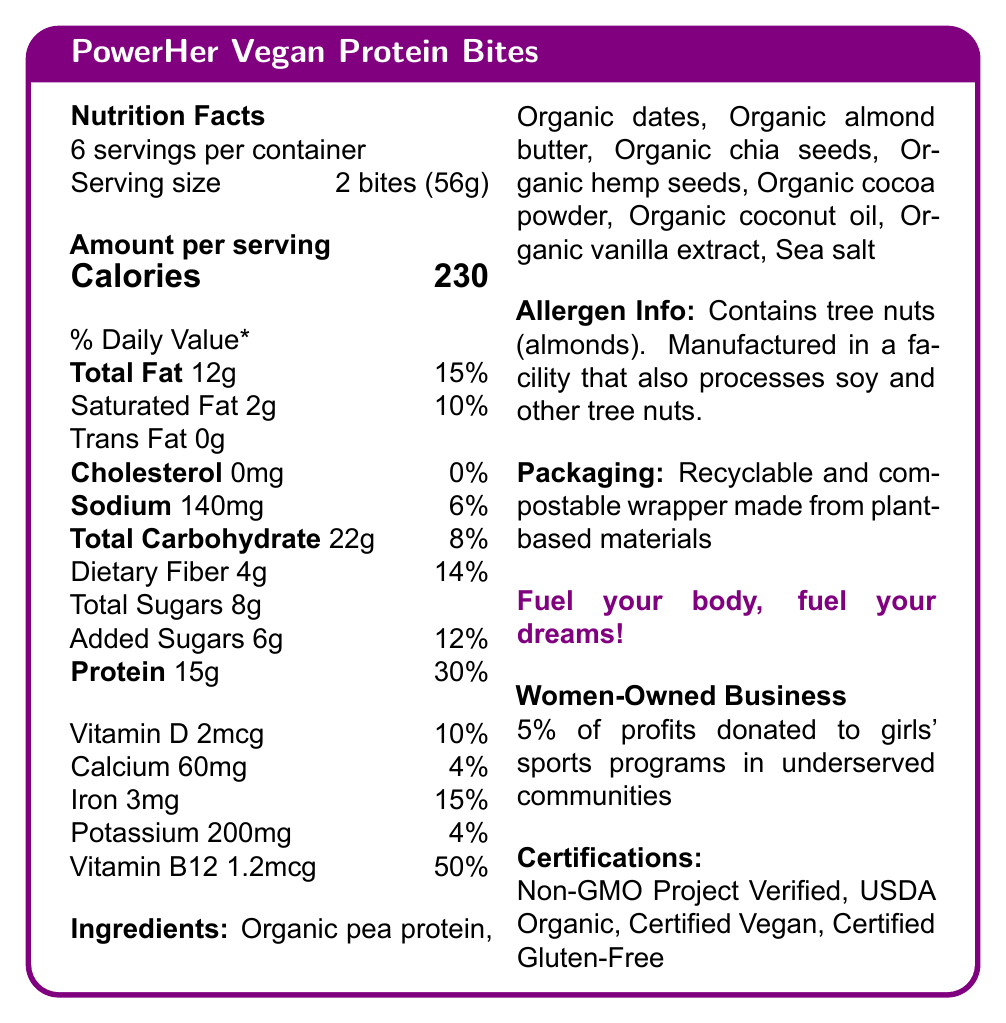what is the serving size of PowerHer Vegan Protein Bites? The document states that the serving size is "2 bites (56g)".
Answer: 2 bites (56g) how many servings are in one container? The document mentions "6 servings per container".
Answer: 6 how many calories are there in one serving? The document indicates "Calories 230" per serving.
Answer: 230 what percentage of the daily value for protein does one serving provide? The document states that the protein content is 15g, which is 30% of the daily value.
Answer: 30% what is the amount of saturated fat per serving? The document lists "Saturated Fat 2g" for one serving.
Answer: 2g what are the main ingredients listed? The ingredients are listed under the "Ingredients" section in the document.
Answer: Organic pea protein, Organic dates, Organic almond butter, Organic chia seeds, Organic hemp seeds, Organic cocoa powder, Organic coconut oil, Organic vanilla extract, Sea salt how much sodium is in one serving, and what percentage of the daily value does this represent? The document indicates "Sodium 140mg" with a daily value of "6%" per serving.
Answer: 140mg, 6% what is the total carbohydrate content per serving? The document lists "Total Carbohydrate 22g" per serving.
Answer: 22g which certifications does the product have? The certifications are mentioned under the "Certifications" section in the document.
Answer: Non-GMO Project Verified, USDA Organic, Certified Vegan, Certified Gluten-Free how much dietary fiber is in one serving? A. 2g B. 4g C. 6g D. 8g The document specifies "Dietary Fiber 4g" per serving as part of the total carbohydrate section.
Answer: B. 4g which vitamin has the highest daily value percentage? A. Vitamin D B. Calcium C. Iron D. Vitamin B12 Vitamin B12 has a daily value of 50%, which is the highest among the vitamins and minerals listed.
Answer: D. Vitamin B12 does the product contain any allergens? The document states "Contains tree nuts (almonds). Manufactured in a facility that also processes soy and other tree nuts".
Answer: Yes does the packaging have any sustainable features? The document describes the packaging as "Recyclable and compostable wrapper made from plant-based materials".
Answer: Yes is this product made by a women-owned business? The document mentions "Women-Owned Business".
Answer: Yes can you tell if the product is gluten-free? The list of certifications includes "Certified Gluten-Free".
Answer: Yes can you summarize the main idea of the document? The document highlights the product's nutritional values, ingredients, allergen info, sustainable packaging, empowering message, women-owned business status, commitment to social impact, and various certifications.
Answer: The document provides nutritional information for PowerHer Vegan Protein Bites, a protein-packed vegan snack for female athletes. It includes details on servings, calories, macronutrients, vitamins, minerals, ingredients, allergen information, packaging, empowering message, business ownership, social impact, and certifications. how much profit is donated to girls' sports programs in underserved communities? The document states "5% of profits donated to girls' sports programs in underserved communities".
Answer: 5% what is the flavor base of the protein bites based on the ingredients? The document lists the ingredients but does not provide information specifically about the flavor profile of the protein bites.
Answer: Not enough information 